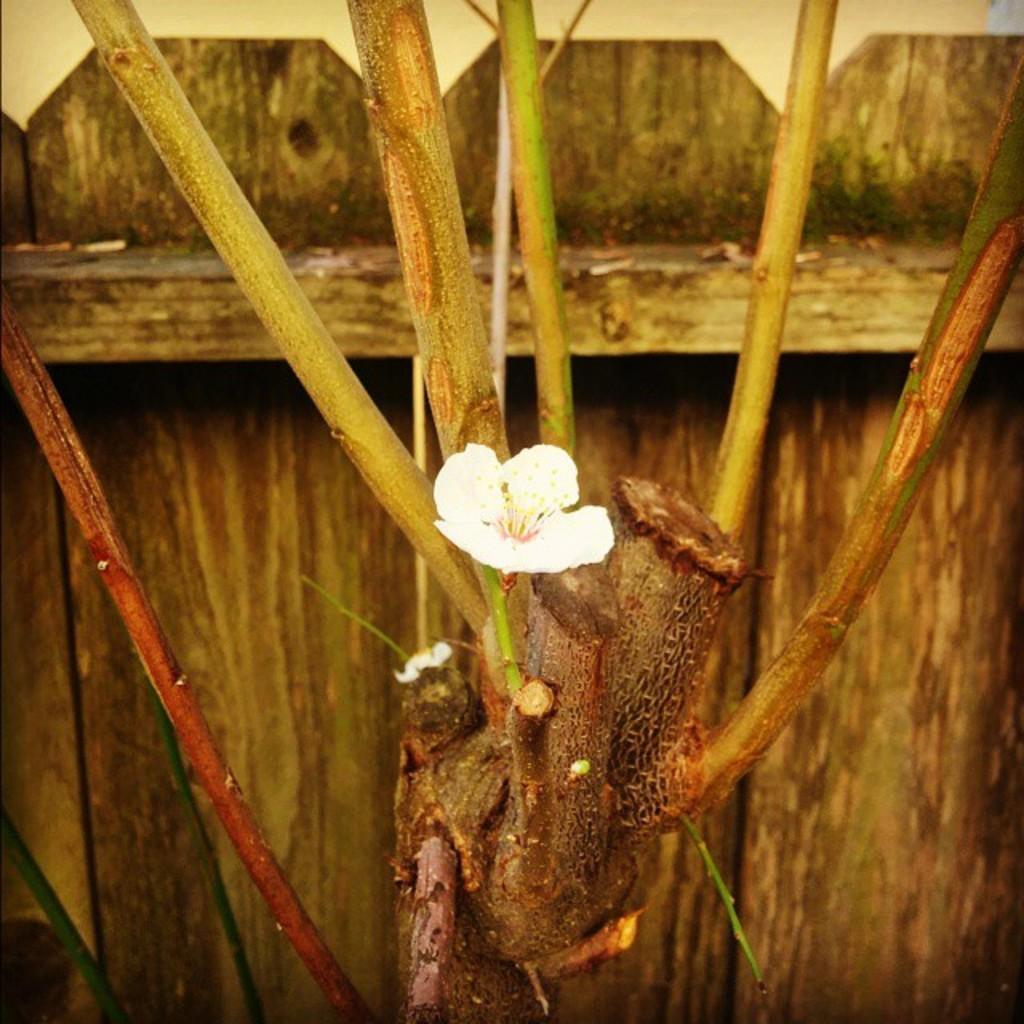Could you give a brief overview of what you see in this image? In the center of the picture there is a plant and there is a flower. In the background there is a wooden wall. 